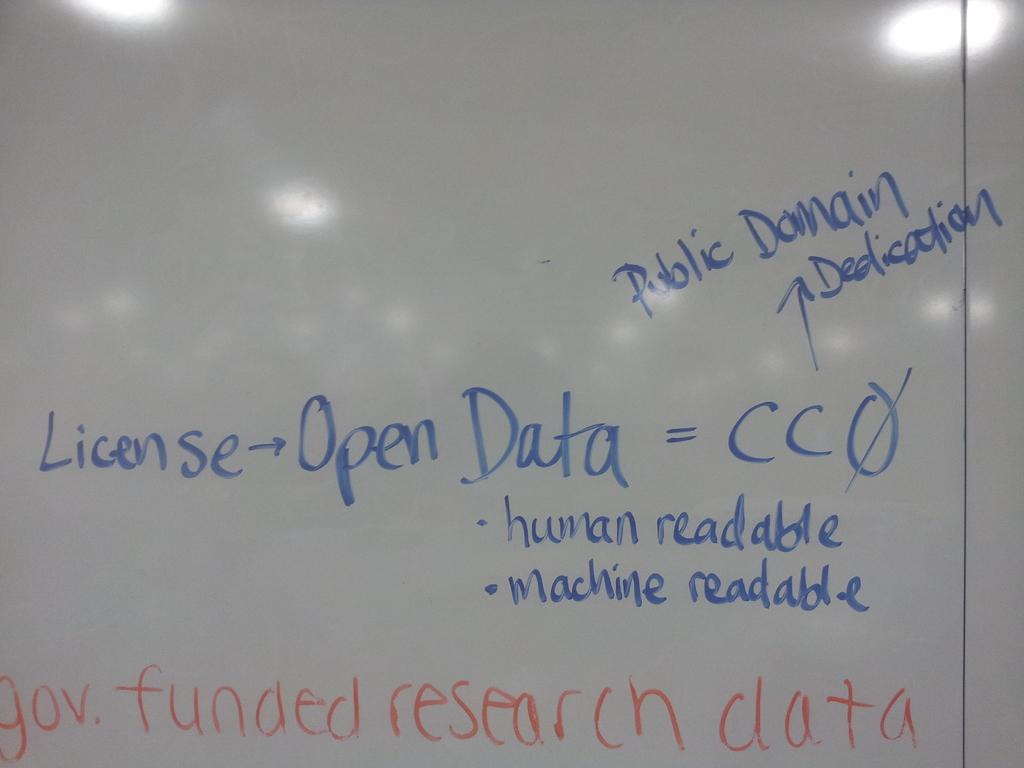<image>
Present a compact description of the photo's key features. A large white dry erase board with the words Public Domain written on it 